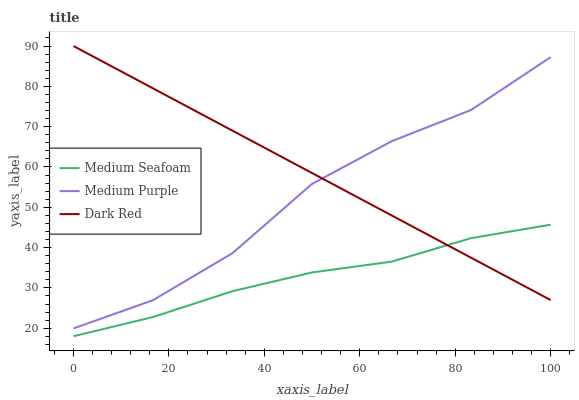Does Dark Red have the minimum area under the curve?
Answer yes or no. No. Does Medium Seafoam have the maximum area under the curve?
Answer yes or no. No. Is Medium Seafoam the smoothest?
Answer yes or no. No. Is Medium Seafoam the roughest?
Answer yes or no. No. Does Dark Red have the lowest value?
Answer yes or no. No. Does Medium Seafoam have the highest value?
Answer yes or no. No. Is Medium Seafoam less than Medium Purple?
Answer yes or no. Yes. Is Medium Purple greater than Medium Seafoam?
Answer yes or no. Yes. Does Medium Seafoam intersect Medium Purple?
Answer yes or no. No. 